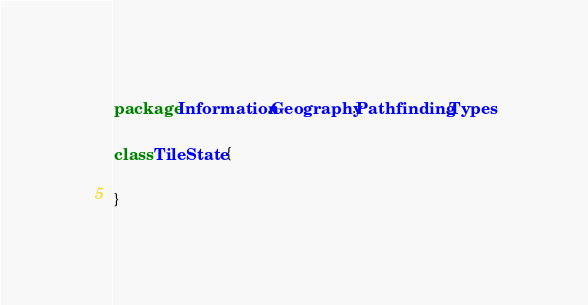Convert code to text. <code><loc_0><loc_0><loc_500><loc_500><_Scala_>package Information.Geography.Pathfinding.Types

class TileState {

}
</code> 